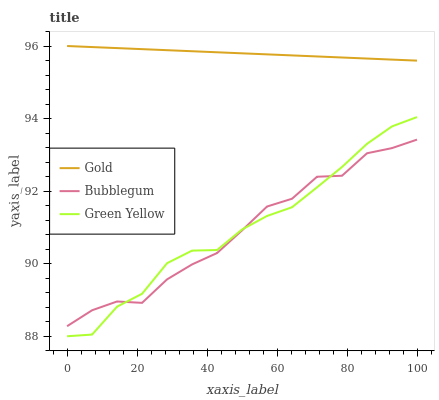Does Bubblegum have the minimum area under the curve?
Answer yes or no. Yes. Does Gold have the maximum area under the curve?
Answer yes or no. Yes. Does Gold have the minimum area under the curve?
Answer yes or no. No. Does Bubblegum have the maximum area under the curve?
Answer yes or no. No. Is Gold the smoothest?
Answer yes or no. Yes. Is Bubblegum the roughest?
Answer yes or no. Yes. Is Bubblegum the smoothest?
Answer yes or no. No. Is Gold the roughest?
Answer yes or no. No. Does Green Yellow have the lowest value?
Answer yes or no. Yes. Does Bubblegum have the lowest value?
Answer yes or no. No. Does Gold have the highest value?
Answer yes or no. Yes. Does Bubblegum have the highest value?
Answer yes or no. No. Is Green Yellow less than Gold?
Answer yes or no. Yes. Is Gold greater than Bubblegum?
Answer yes or no. Yes. Does Green Yellow intersect Bubblegum?
Answer yes or no. Yes. Is Green Yellow less than Bubblegum?
Answer yes or no. No. Is Green Yellow greater than Bubblegum?
Answer yes or no. No. Does Green Yellow intersect Gold?
Answer yes or no. No. 